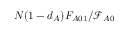Convert formula to latex. <formula><loc_0><loc_0><loc_500><loc_500>N ( 1 - d _ { A } ) F _ { A 0 1 } / \mathcal { F } _ { A 0 }</formula> 